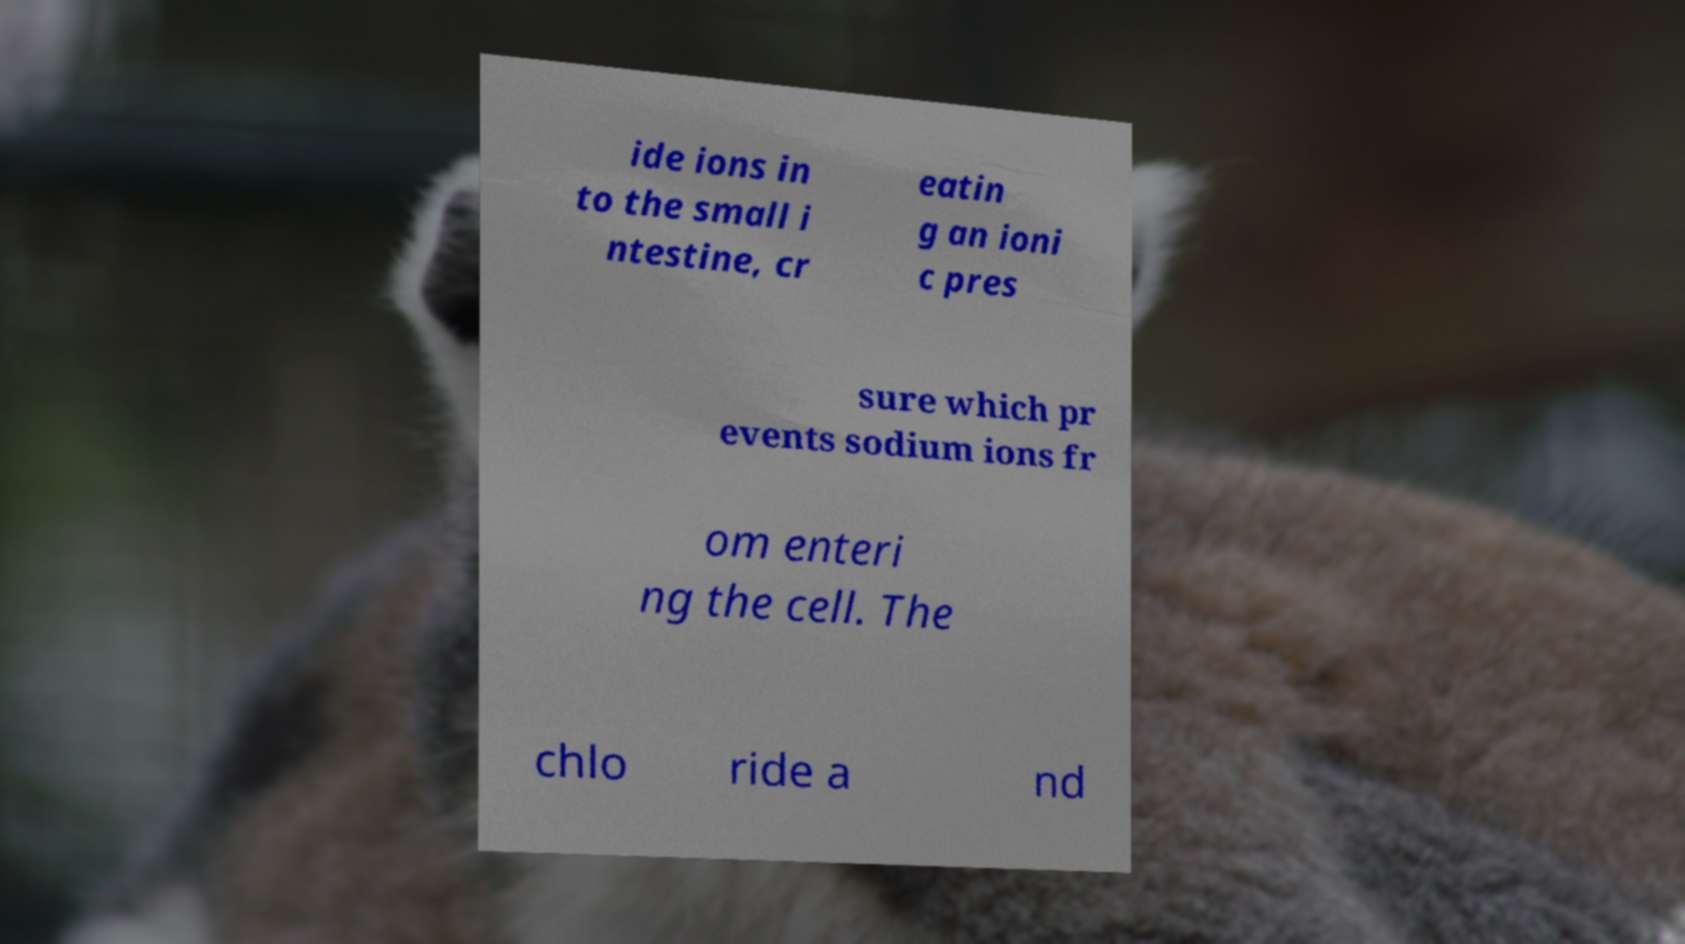Can you read and provide the text displayed in the image?This photo seems to have some interesting text. Can you extract and type it out for me? ide ions in to the small i ntestine, cr eatin g an ioni c pres sure which pr events sodium ions fr om enteri ng the cell. The chlo ride a nd 